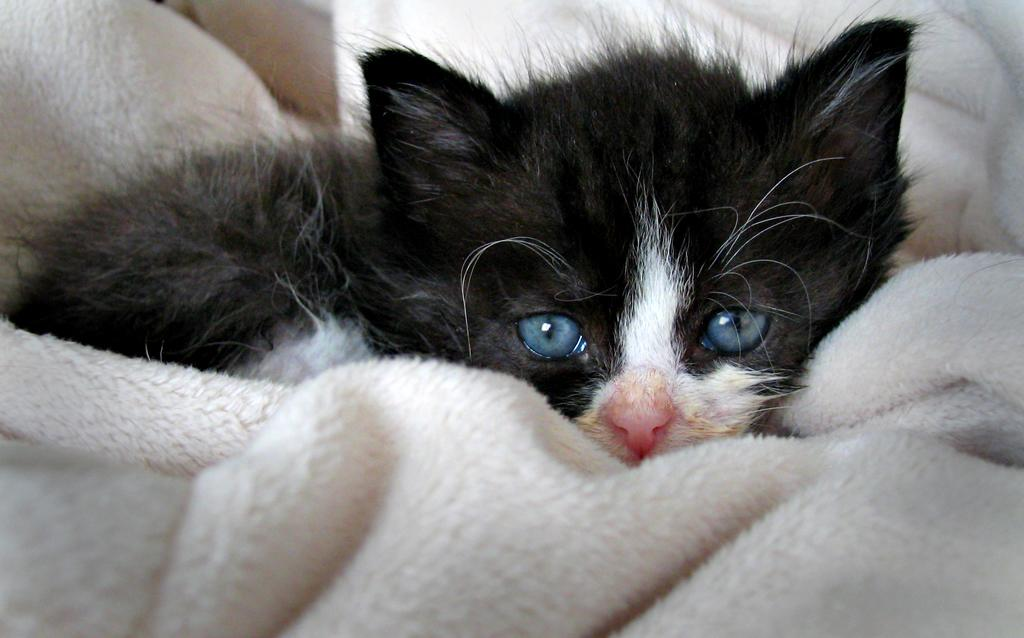What type of animal is in the image? There is a cat in the image. What is the cat sitting on? The cat is sitting on a cloth. Can you see a zipper on the cat in the image? There is no zipper present on the cat in the image. What type of pipe is visible in the image? There is no pipe present in the image. 